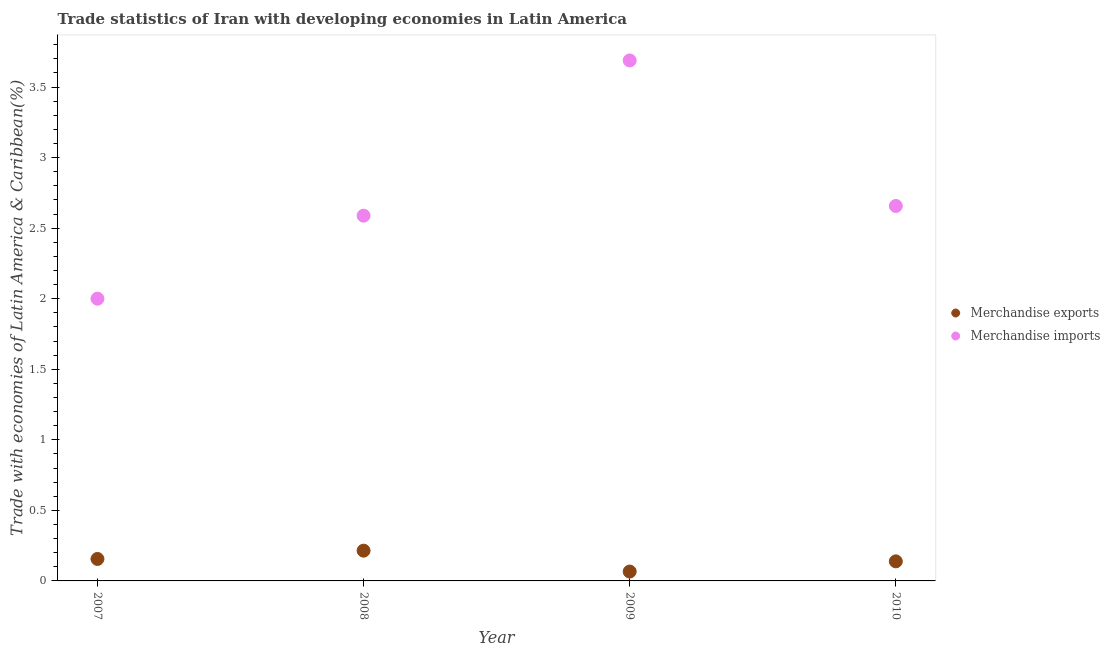What is the merchandise exports in 2008?
Give a very brief answer. 0.21. Across all years, what is the maximum merchandise imports?
Give a very brief answer. 3.69. Across all years, what is the minimum merchandise imports?
Offer a terse response. 2. What is the total merchandise imports in the graph?
Give a very brief answer. 10.93. What is the difference between the merchandise imports in 2009 and that in 2010?
Offer a terse response. 1.03. What is the difference between the merchandise imports in 2007 and the merchandise exports in 2008?
Your answer should be very brief. 1.79. What is the average merchandise exports per year?
Your answer should be very brief. 0.14. In the year 2007, what is the difference between the merchandise exports and merchandise imports?
Your response must be concise. -1.84. In how many years, is the merchandise exports greater than 1.7 %?
Your answer should be compact. 0. What is the ratio of the merchandise imports in 2009 to that in 2010?
Your answer should be compact. 1.39. Is the merchandise imports in 2007 less than that in 2010?
Your answer should be compact. Yes. Is the difference between the merchandise exports in 2007 and 2009 greater than the difference between the merchandise imports in 2007 and 2009?
Provide a short and direct response. Yes. What is the difference between the highest and the second highest merchandise exports?
Your answer should be compact. 0.06. What is the difference between the highest and the lowest merchandise exports?
Offer a terse response. 0.15. Is the sum of the merchandise imports in 2008 and 2009 greater than the maximum merchandise exports across all years?
Provide a succinct answer. Yes. Does the merchandise imports monotonically increase over the years?
Your answer should be compact. No. How many dotlines are there?
Your answer should be compact. 2. What is the difference between two consecutive major ticks on the Y-axis?
Offer a terse response. 0.5. What is the title of the graph?
Give a very brief answer. Trade statistics of Iran with developing economies in Latin America. What is the label or title of the Y-axis?
Offer a terse response. Trade with economies of Latin America & Caribbean(%). What is the Trade with economies of Latin America & Caribbean(%) in Merchandise exports in 2007?
Ensure brevity in your answer.  0.16. What is the Trade with economies of Latin America & Caribbean(%) in Merchandise imports in 2007?
Offer a terse response. 2. What is the Trade with economies of Latin America & Caribbean(%) of Merchandise exports in 2008?
Provide a short and direct response. 0.21. What is the Trade with economies of Latin America & Caribbean(%) in Merchandise imports in 2008?
Ensure brevity in your answer.  2.59. What is the Trade with economies of Latin America & Caribbean(%) of Merchandise exports in 2009?
Offer a terse response. 0.07. What is the Trade with economies of Latin America & Caribbean(%) of Merchandise imports in 2009?
Your response must be concise. 3.69. What is the Trade with economies of Latin America & Caribbean(%) of Merchandise exports in 2010?
Make the answer very short. 0.14. What is the Trade with economies of Latin America & Caribbean(%) in Merchandise imports in 2010?
Your answer should be compact. 2.66. Across all years, what is the maximum Trade with economies of Latin America & Caribbean(%) in Merchandise exports?
Offer a very short reply. 0.21. Across all years, what is the maximum Trade with economies of Latin America & Caribbean(%) of Merchandise imports?
Offer a very short reply. 3.69. Across all years, what is the minimum Trade with economies of Latin America & Caribbean(%) in Merchandise exports?
Offer a terse response. 0.07. What is the total Trade with economies of Latin America & Caribbean(%) in Merchandise exports in the graph?
Your answer should be very brief. 0.58. What is the total Trade with economies of Latin America & Caribbean(%) of Merchandise imports in the graph?
Make the answer very short. 10.93. What is the difference between the Trade with economies of Latin America & Caribbean(%) in Merchandise exports in 2007 and that in 2008?
Make the answer very short. -0.06. What is the difference between the Trade with economies of Latin America & Caribbean(%) of Merchandise imports in 2007 and that in 2008?
Make the answer very short. -0.59. What is the difference between the Trade with economies of Latin America & Caribbean(%) in Merchandise exports in 2007 and that in 2009?
Provide a succinct answer. 0.09. What is the difference between the Trade with economies of Latin America & Caribbean(%) of Merchandise imports in 2007 and that in 2009?
Give a very brief answer. -1.69. What is the difference between the Trade with economies of Latin America & Caribbean(%) in Merchandise exports in 2007 and that in 2010?
Provide a succinct answer. 0.02. What is the difference between the Trade with economies of Latin America & Caribbean(%) of Merchandise imports in 2007 and that in 2010?
Offer a very short reply. -0.66. What is the difference between the Trade with economies of Latin America & Caribbean(%) of Merchandise exports in 2008 and that in 2009?
Your answer should be compact. 0.15. What is the difference between the Trade with economies of Latin America & Caribbean(%) of Merchandise imports in 2008 and that in 2009?
Provide a short and direct response. -1.1. What is the difference between the Trade with economies of Latin America & Caribbean(%) of Merchandise exports in 2008 and that in 2010?
Provide a short and direct response. 0.08. What is the difference between the Trade with economies of Latin America & Caribbean(%) in Merchandise imports in 2008 and that in 2010?
Your answer should be compact. -0.07. What is the difference between the Trade with economies of Latin America & Caribbean(%) of Merchandise exports in 2009 and that in 2010?
Your response must be concise. -0.07. What is the difference between the Trade with economies of Latin America & Caribbean(%) in Merchandise imports in 2009 and that in 2010?
Keep it short and to the point. 1.03. What is the difference between the Trade with economies of Latin America & Caribbean(%) in Merchandise exports in 2007 and the Trade with economies of Latin America & Caribbean(%) in Merchandise imports in 2008?
Give a very brief answer. -2.43. What is the difference between the Trade with economies of Latin America & Caribbean(%) in Merchandise exports in 2007 and the Trade with economies of Latin America & Caribbean(%) in Merchandise imports in 2009?
Your answer should be compact. -3.53. What is the difference between the Trade with economies of Latin America & Caribbean(%) of Merchandise exports in 2007 and the Trade with economies of Latin America & Caribbean(%) of Merchandise imports in 2010?
Give a very brief answer. -2.5. What is the difference between the Trade with economies of Latin America & Caribbean(%) in Merchandise exports in 2008 and the Trade with economies of Latin America & Caribbean(%) in Merchandise imports in 2009?
Keep it short and to the point. -3.47. What is the difference between the Trade with economies of Latin America & Caribbean(%) of Merchandise exports in 2008 and the Trade with economies of Latin America & Caribbean(%) of Merchandise imports in 2010?
Your answer should be compact. -2.44. What is the difference between the Trade with economies of Latin America & Caribbean(%) of Merchandise exports in 2009 and the Trade with economies of Latin America & Caribbean(%) of Merchandise imports in 2010?
Keep it short and to the point. -2.59. What is the average Trade with economies of Latin America & Caribbean(%) in Merchandise exports per year?
Your response must be concise. 0.14. What is the average Trade with economies of Latin America & Caribbean(%) in Merchandise imports per year?
Your answer should be very brief. 2.73. In the year 2007, what is the difference between the Trade with economies of Latin America & Caribbean(%) in Merchandise exports and Trade with economies of Latin America & Caribbean(%) in Merchandise imports?
Keep it short and to the point. -1.84. In the year 2008, what is the difference between the Trade with economies of Latin America & Caribbean(%) of Merchandise exports and Trade with economies of Latin America & Caribbean(%) of Merchandise imports?
Ensure brevity in your answer.  -2.37. In the year 2009, what is the difference between the Trade with economies of Latin America & Caribbean(%) in Merchandise exports and Trade with economies of Latin America & Caribbean(%) in Merchandise imports?
Offer a very short reply. -3.62. In the year 2010, what is the difference between the Trade with economies of Latin America & Caribbean(%) of Merchandise exports and Trade with economies of Latin America & Caribbean(%) of Merchandise imports?
Your answer should be compact. -2.52. What is the ratio of the Trade with economies of Latin America & Caribbean(%) of Merchandise exports in 2007 to that in 2008?
Offer a terse response. 0.73. What is the ratio of the Trade with economies of Latin America & Caribbean(%) in Merchandise imports in 2007 to that in 2008?
Ensure brevity in your answer.  0.77. What is the ratio of the Trade with economies of Latin America & Caribbean(%) in Merchandise exports in 2007 to that in 2009?
Provide a short and direct response. 2.34. What is the ratio of the Trade with economies of Latin America & Caribbean(%) in Merchandise imports in 2007 to that in 2009?
Ensure brevity in your answer.  0.54. What is the ratio of the Trade with economies of Latin America & Caribbean(%) in Merchandise exports in 2007 to that in 2010?
Your answer should be compact. 1.12. What is the ratio of the Trade with economies of Latin America & Caribbean(%) of Merchandise imports in 2007 to that in 2010?
Provide a short and direct response. 0.75. What is the ratio of the Trade with economies of Latin America & Caribbean(%) of Merchandise exports in 2008 to that in 2009?
Your response must be concise. 3.23. What is the ratio of the Trade with economies of Latin America & Caribbean(%) of Merchandise imports in 2008 to that in 2009?
Provide a succinct answer. 0.7. What is the ratio of the Trade with economies of Latin America & Caribbean(%) in Merchandise exports in 2008 to that in 2010?
Keep it short and to the point. 1.55. What is the ratio of the Trade with economies of Latin America & Caribbean(%) in Merchandise imports in 2008 to that in 2010?
Offer a very short reply. 0.97. What is the ratio of the Trade with economies of Latin America & Caribbean(%) of Merchandise exports in 2009 to that in 2010?
Give a very brief answer. 0.48. What is the ratio of the Trade with economies of Latin America & Caribbean(%) in Merchandise imports in 2009 to that in 2010?
Ensure brevity in your answer.  1.39. What is the difference between the highest and the second highest Trade with economies of Latin America & Caribbean(%) in Merchandise exports?
Your response must be concise. 0.06. What is the difference between the highest and the second highest Trade with economies of Latin America & Caribbean(%) of Merchandise imports?
Give a very brief answer. 1.03. What is the difference between the highest and the lowest Trade with economies of Latin America & Caribbean(%) in Merchandise exports?
Provide a succinct answer. 0.15. What is the difference between the highest and the lowest Trade with economies of Latin America & Caribbean(%) in Merchandise imports?
Offer a very short reply. 1.69. 